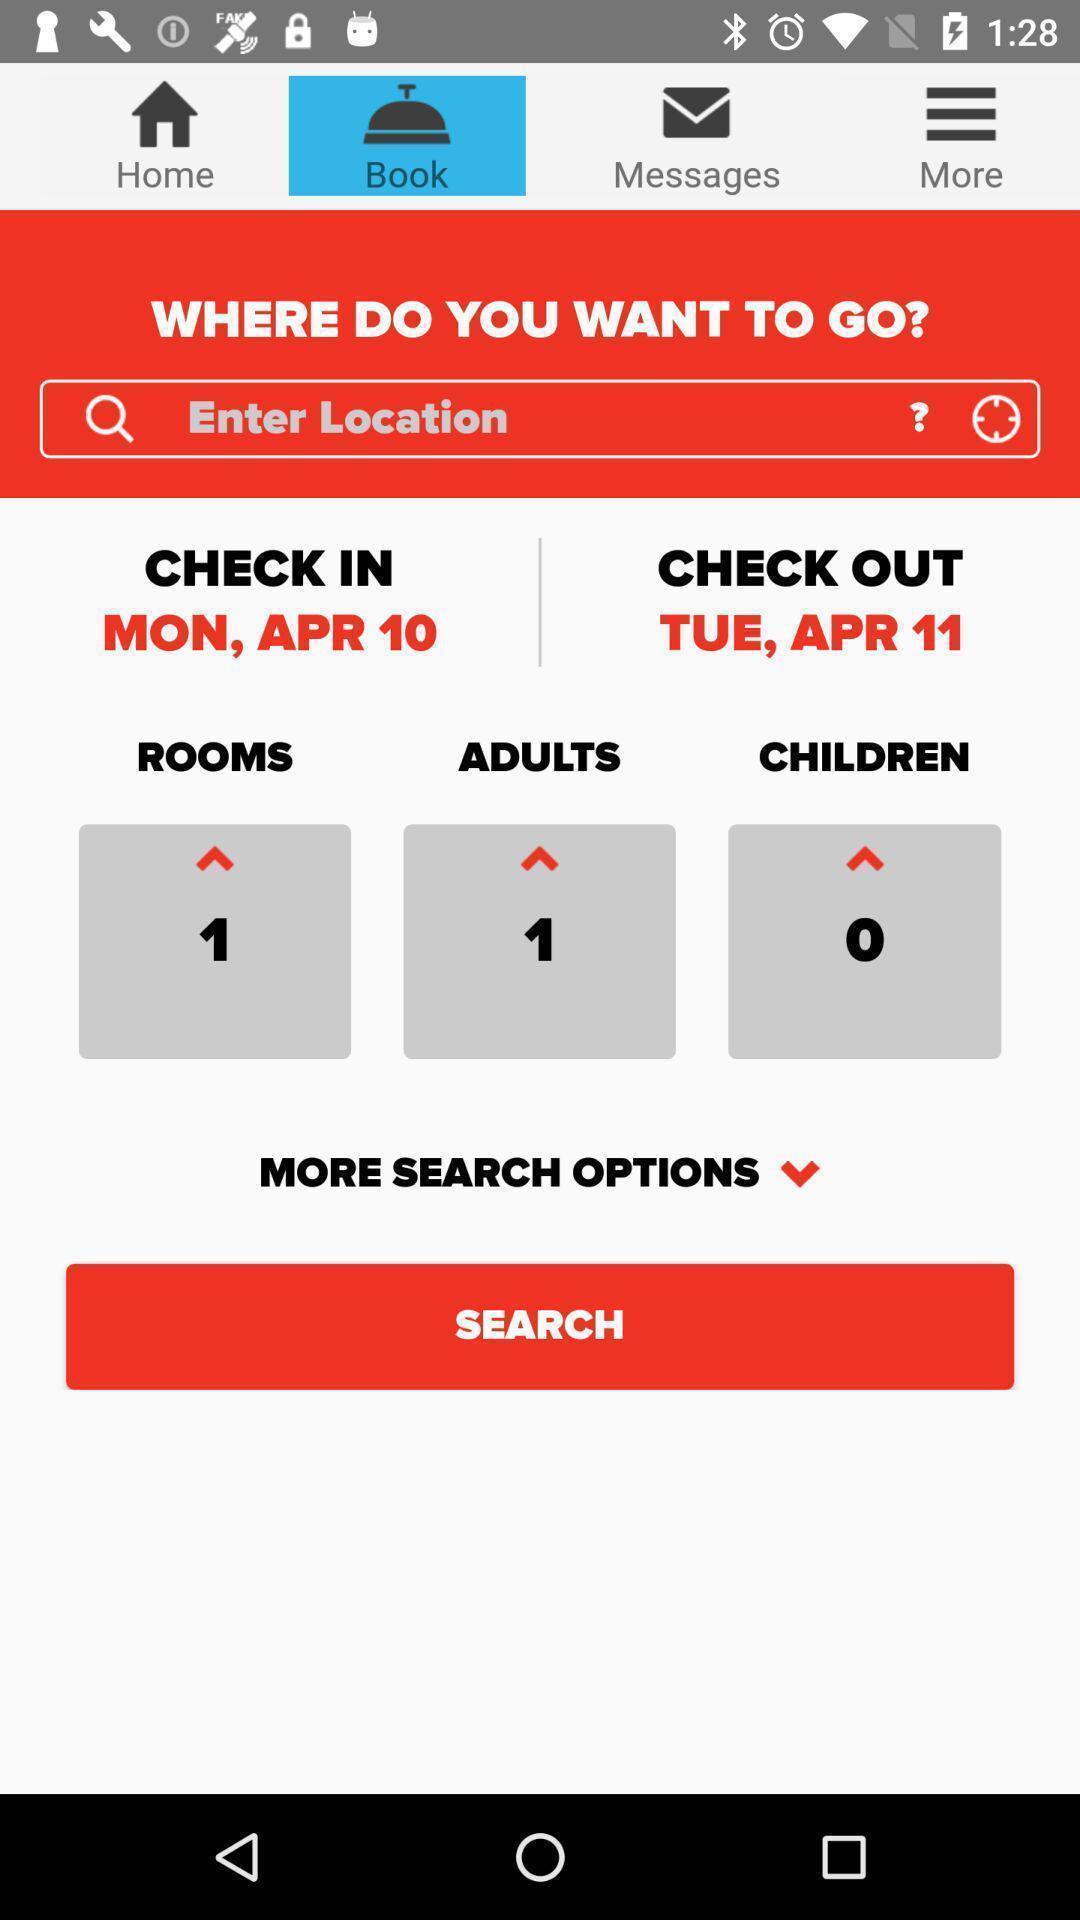Summarize the main components in this picture. Search page for searching a location for dining. 